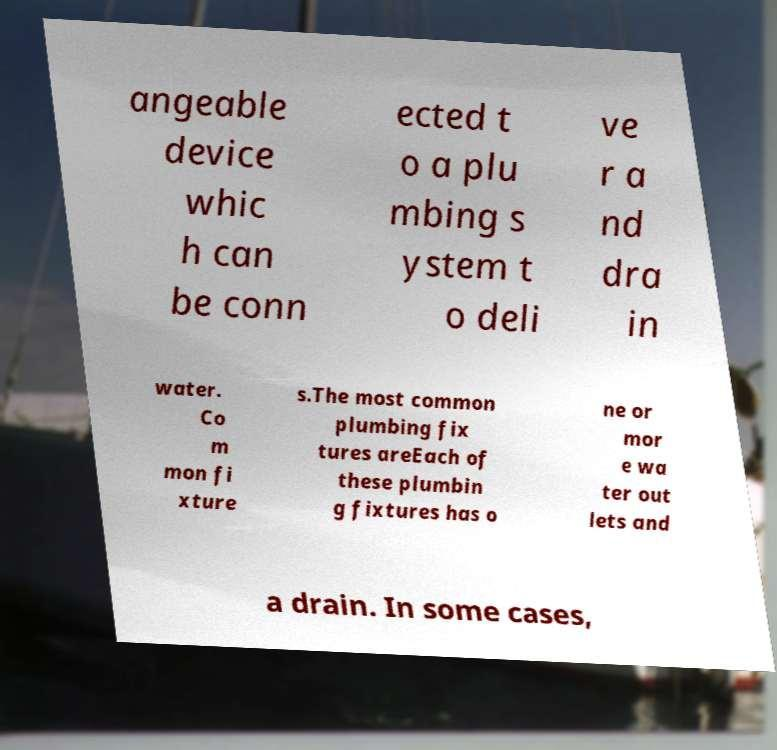Can you accurately transcribe the text from the provided image for me? angeable device whic h can be conn ected t o a plu mbing s ystem t o deli ve r a nd dra in water. Co m mon fi xture s.The most common plumbing fix tures areEach of these plumbin g fixtures has o ne or mor e wa ter out lets and a drain. In some cases, 